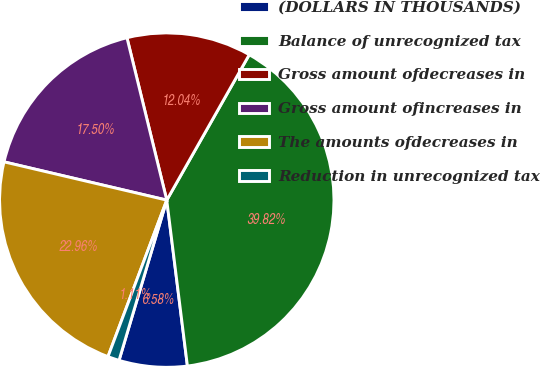Convert chart. <chart><loc_0><loc_0><loc_500><loc_500><pie_chart><fcel>(DOLLARS IN THOUSANDS)<fcel>Balance of unrecognized tax<fcel>Gross amount ofdecreases in<fcel>Gross amount ofincreases in<fcel>The amounts ofdecreases in<fcel>Reduction in unrecognized tax<nl><fcel>6.58%<fcel>39.82%<fcel>12.04%<fcel>17.5%<fcel>22.96%<fcel>1.11%<nl></chart> 